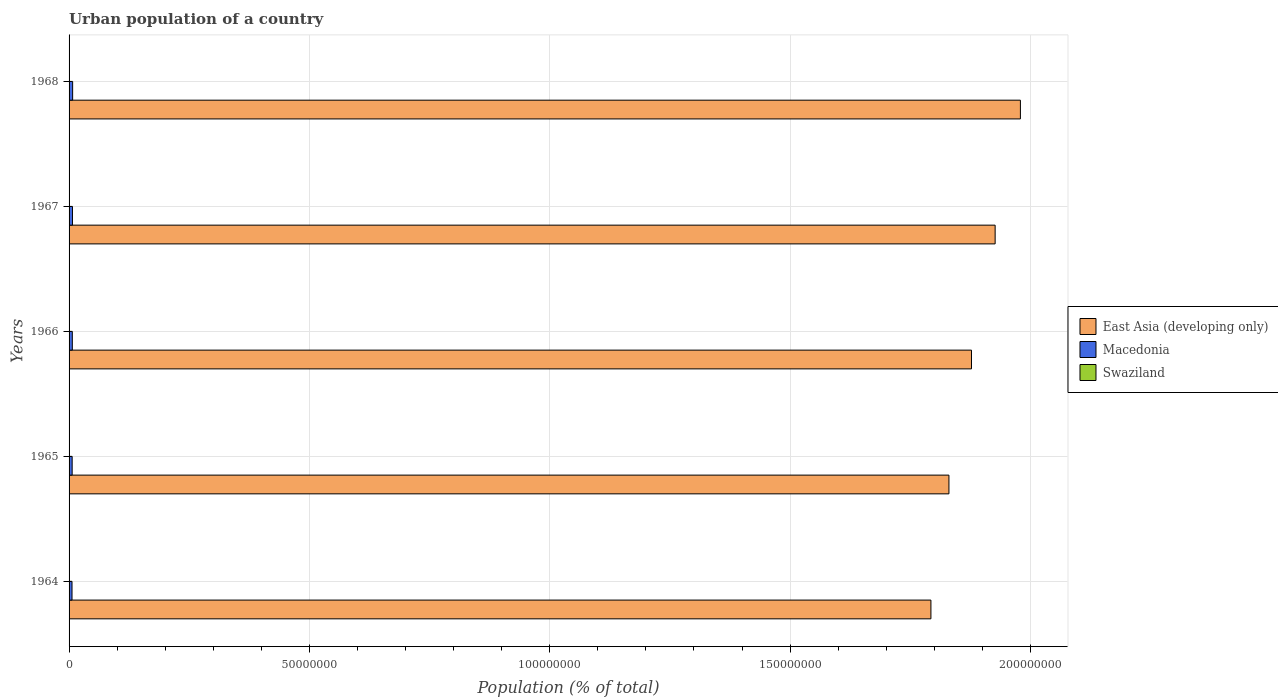How many different coloured bars are there?
Make the answer very short. 3. How many bars are there on the 5th tick from the top?
Ensure brevity in your answer.  3. What is the label of the 3rd group of bars from the top?
Provide a succinct answer. 1966. What is the urban population in East Asia (developing only) in 1967?
Offer a terse response. 1.93e+08. Across all years, what is the maximum urban population in Macedonia?
Offer a terse response. 7.42e+05. Across all years, what is the minimum urban population in East Asia (developing only)?
Offer a terse response. 1.79e+08. In which year was the urban population in East Asia (developing only) maximum?
Provide a short and direct response. 1968. In which year was the urban population in East Asia (developing only) minimum?
Give a very brief answer. 1964. What is the total urban population in Macedonia in the graph?
Keep it short and to the point. 3.38e+06. What is the difference between the urban population in East Asia (developing only) in 1966 and that in 1968?
Offer a terse response. -1.02e+07. What is the difference between the urban population in Macedonia in 1965 and the urban population in East Asia (developing only) in 1968?
Ensure brevity in your answer.  -1.97e+08. What is the average urban population in East Asia (developing only) per year?
Your response must be concise. 1.88e+08. In the year 1964, what is the difference between the urban population in East Asia (developing only) and urban population in Macedonia?
Your answer should be very brief. 1.79e+08. What is the ratio of the urban population in Macedonia in 1967 to that in 1968?
Ensure brevity in your answer.  0.95. Is the urban population in Swaziland in 1964 less than that in 1968?
Provide a short and direct response. Yes. Is the difference between the urban population in East Asia (developing only) in 1964 and 1965 greater than the difference between the urban population in Macedonia in 1964 and 1965?
Give a very brief answer. No. What is the difference between the highest and the second highest urban population in Macedonia?
Keep it short and to the point. 3.44e+04. What is the difference between the highest and the lowest urban population in East Asia (developing only)?
Offer a very short reply. 1.86e+07. Is the sum of the urban population in Swaziland in 1967 and 1968 greater than the maximum urban population in Macedonia across all years?
Keep it short and to the point. No. What does the 3rd bar from the top in 1967 represents?
Offer a very short reply. East Asia (developing only). What does the 2nd bar from the bottom in 1965 represents?
Give a very brief answer. Macedonia. How many bars are there?
Provide a succinct answer. 15. Are all the bars in the graph horizontal?
Make the answer very short. Yes. What is the difference between two consecutive major ticks on the X-axis?
Keep it short and to the point. 5.00e+07. Are the values on the major ticks of X-axis written in scientific E-notation?
Your answer should be compact. No. Does the graph contain any zero values?
Provide a succinct answer. No. How many legend labels are there?
Offer a very short reply. 3. How are the legend labels stacked?
Your response must be concise. Vertical. What is the title of the graph?
Keep it short and to the point. Urban population of a country. Does "Chad" appear as one of the legend labels in the graph?
Your answer should be compact. No. What is the label or title of the X-axis?
Ensure brevity in your answer.  Population (% of total). What is the Population (% of total) in East Asia (developing only) in 1964?
Ensure brevity in your answer.  1.79e+08. What is the Population (% of total) of Macedonia in 1964?
Provide a succinct answer. 6.13e+05. What is the Population (% of total) in Swaziland in 1964?
Make the answer very short. 2.25e+04. What is the Population (% of total) of East Asia (developing only) in 1965?
Make the answer very short. 1.83e+08. What is the Population (% of total) of Macedonia in 1965?
Your answer should be very brief. 6.43e+05. What is the Population (% of total) of Swaziland in 1965?
Make the answer very short. 2.54e+04. What is the Population (% of total) of East Asia (developing only) in 1966?
Your response must be concise. 1.88e+08. What is the Population (% of total) of Macedonia in 1966?
Your answer should be very brief. 6.74e+05. What is the Population (% of total) in Swaziland in 1966?
Provide a short and direct response. 2.87e+04. What is the Population (% of total) in East Asia (developing only) in 1967?
Ensure brevity in your answer.  1.93e+08. What is the Population (% of total) of Macedonia in 1967?
Your answer should be compact. 7.08e+05. What is the Population (% of total) of Swaziland in 1967?
Make the answer very short. 3.18e+04. What is the Population (% of total) of East Asia (developing only) in 1968?
Give a very brief answer. 1.98e+08. What is the Population (% of total) in Macedonia in 1968?
Provide a succinct answer. 7.42e+05. What is the Population (% of total) in Swaziland in 1968?
Your answer should be very brief. 3.52e+04. Across all years, what is the maximum Population (% of total) in East Asia (developing only)?
Provide a succinct answer. 1.98e+08. Across all years, what is the maximum Population (% of total) of Macedonia?
Provide a short and direct response. 7.42e+05. Across all years, what is the maximum Population (% of total) in Swaziland?
Make the answer very short. 3.52e+04. Across all years, what is the minimum Population (% of total) in East Asia (developing only)?
Make the answer very short. 1.79e+08. Across all years, what is the minimum Population (% of total) of Macedonia?
Offer a terse response. 6.13e+05. Across all years, what is the minimum Population (% of total) in Swaziland?
Provide a succinct answer. 2.25e+04. What is the total Population (% of total) in East Asia (developing only) in the graph?
Ensure brevity in your answer.  9.41e+08. What is the total Population (% of total) in Macedonia in the graph?
Give a very brief answer. 3.38e+06. What is the total Population (% of total) in Swaziland in the graph?
Offer a terse response. 1.44e+05. What is the difference between the Population (% of total) of East Asia (developing only) in 1964 and that in 1965?
Your answer should be very brief. -3.75e+06. What is the difference between the Population (% of total) in Macedonia in 1964 and that in 1965?
Provide a short and direct response. -2.99e+04. What is the difference between the Population (% of total) in Swaziland in 1964 and that in 1965?
Offer a very short reply. -2954. What is the difference between the Population (% of total) in East Asia (developing only) in 1964 and that in 1966?
Ensure brevity in your answer.  -8.44e+06. What is the difference between the Population (% of total) of Macedonia in 1964 and that in 1966?
Your answer should be very brief. -6.16e+04. What is the difference between the Population (% of total) in Swaziland in 1964 and that in 1966?
Keep it short and to the point. -6241. What is the difference between the Population (% of total) in East Asia (developing only) in 1964 and that in 1967?
Keep it short and to the point. -1.34e+07. What is the difference between the Population (% of total) in Macedonia in 1964 and that in 1967?
Your answer should be very brief. -9.49e+04. What is the difference between the Population (% of total) of Swaziland in 1964 and that in 1967?
Your answer should be very brief. -9323. What is the difference between the Population (% of total) of East Asia (developing only) in 1964 and that in 1968?
Offer a very short reply. -1.86e+07. What is the difference between the Population (% of total) of Macedonia in 1964 and that in 1968?
Keep it short and to the point. -1.29e+05. What is the difference between the Population (% of total) of Swaziland in 1964 and that in 1968?
Offer a terse response. -1.28e+04. What is the difference between the Population (% of total) of East Asia (developing only) in 1965 and that in 1966?
Offer a very short reply. -4.69e+06. What is the difference between the Population (% of total) of Macedonia in 1965 and that in 1966?
Provide a short and direct response. -3.17e+04. What is the difference between the Population (% of total) in Swaziland in 1965 and that in 1966?
Make the answer very short. -3287. What is the difference between the Population (% of total) in East Asia (developing only) in 1965 and that in 1967?
Your answer should be very brief. -9.61e+06. What is the difference between the Population (% of total) in Macedonia in 1965 and that in 1967?
Provide a short and direct response. -6.50e+04. What is the difference between the Population (% of total) of Swaziland in 1965 and that in 1967?
Ensure brevity in your answer.  -6369. What is the difference between the Population (% of total) in East Asia (developing only) in 1965 and that in 1968?
Provide a succinct answer. -1.49e+07. What is the difference between the Population (% of total) of Macedonia in 1965 and that in 1968?
Your response must be concise. -9.93e+04. What is the difference between the Population (% of total) of Swaziland in 1965 and that in 1968?
Provide a succinct answer. -9800. What is the difference between the Population (% of total) of East Asia (developing only) in 1966 and that in 1967?
Your answer should be compact. -4.92e+06. What is the difference between the Population (% of total) in Macedonia in 1966 and that in 1967?
Give a very brief answer. -3.33e+04. What is the difference between the Population (% of total) of Swaziland in 1966 and that in 1967?
Give a very brief answer. -3082. What is the difference between the Population (% of total) in East Asia (developing only) in 1966 and that in 1968?
Offer a terse response. -1.02e+07. What is the difference between the Population (% of total) in Macedonia in 1966 and that in 1968?
Your response must be concise. -6.76e+04. What is the difference between the Population (% of total) of Swaziland in 1966 and that in 1968?
Offer a terse response. -6513. What is the difference between the Population (% of total) in East Asia (developing only) in 1967 and that in 1968?
Offer a terse response. -5.26e+06. What is the difference between the Population (% of total) of Macedonia in 1967 and that in 1968?
Ensure brevity in your answer.  -3.44e+04. What is the difference between the Population (% of total) of Swaziland in 1967 and that in 1968?
Provide a short and direct response. -3431. What is the difference between the Population (% of total) of East Asia (developing only) in 1964 and the Population (% of total) of Macedonia in 1965?
Give a very brief answer. 1.79e+08. What is the difference between the Population (% of total) of East Asia (developing only) in 1964 and the Population (% of total) of Swaziland in 1965?
Your answer should be very brief. 1.79e+08. What is the difference between the Population (% of total) in Macedonia in 1964 and the Population (% of total) in Swaziland in 1965?
Your response must be concise. 5.87e+05. What is the difference between the Population (% of total) of East Asia (developing only) in 1964 and the Population (% of total) of Macedonia in 1966?
Give a very brief answer. 1.79e+08. What is the difference between the Population (% of total) of East Asia (developing only) in 1964 and the Population (% of total) of Swaziland in 1966?
Provide a short and direct response. 1.79e+08. What is the difference between the Population (% of total) of Macedonia in 1964 and the Population (% of total) of Swaziland in 1966?
Offer a very short reply. 5.84e+05. What is the difference between the Population (% of total) of East Asia (developing only) in 1964 and the Population (% of total) of Macedonia in 1967?
Offer a very short reply. 1.79e+08. What is the difference between the Population (% of total) of East Asia (developing only) in 1964 and the Population (% of total) of Swaziland in 1967?
Provide a succinct answer. 1.79e+08. What is the difference between the Population (% of total) of Macedonia in 1964 and the Population (% of total) of Swaziland in 1967?
Make the answer very short. 5.81e+05. What is the difference between the Population (% of total) of East Asia (developing only) in 1964 and the Population (% of total) of Macedonia in 1968?
Your answer should be compact. 1.79e+08. What is the difference between the Population (% of total) in East Asia (developing only) in 1964 and the Population (% of total) in Swaziland in 1968?
Offer a terse response. 1.79e+08. What is the difference between the Population (% of total) of Macedonia in 1964 and the Population (% of total) of Swaziland in 1968?
Keep it short and to the point. 5.77e+05. What is the difference between the Population (% of total) in East Asia (developing only) in 1965 and the Population (% of total) in Macedonia in 1966?
Your answer should be very brief. 1.82e+08. What is the difference between the Population (% of total) of East Asia (developing only) in 1965 and the Population (% of total) of Swaziland in 1966?
Ensure brevity in your answer.  1.83e+08. What is the difference between the Population (% of total) of Macedonia in 1965 and the Population (% of total) of Swaziland in 1966?
Your answer should be compact. 6.14e+05. What is the difference between the Population (% of total) in East Asia (developing only) in 1965 and the Population (% of total) in Macedonia in 1967?
Offer a terse response. 1.82e+08. What is the difference between the Population (% of total) of East Asia (developing only) in 1965 and the Population (% of total) of Swaziland in 1967?
Your answer should be very brief. 1.83e+08. What is the difference between the Population (% of total) of Macedonia in 1965 and the Population (% of total) of Swaziland in 1967?
Ensure brevity in your answer.  6.11e+05. What is the difference between the Population (% of total) of East Asia (developing only) in 1965 and the Population (% of total) of Macedonia in 1968?
Ensure brevity in your answer.  1.82e+08. What is the difference between the Population (% of total) in East Asia (developing only) in 1965 and the Population (% of total) in Swaziland in 1968?
Provide a short and direct response. 1.83e+08. What is the difference between the Population (% of total) of Macedonia in 1965 and the Population (% of total) of Swaziland in 1968?
Provide a succinct answer. 6.07e+05. What is the difference between the Population (% of total) of East Asia (developing only) in 1966 and the Population (% of total) of Macedonia in 1967?
Ensure brevity in your answer.  1.87e+08. What is the difference between the Population (% of total) in East Asia (developing only) in 1966 and the Population (% of total) in Swaziland in 1967?
Your answer should be very brief. 1.88e+08. What is the difference between the Population (% of total) in Macedonia in 1966 and the Population (% of total) in Swaziland in 1967?
Your answer should be compact. 6.42e+05. What is the difference between the Population (% of total) in East Asia (developing only) in 1966 and the Population (% of total) in Macedonia in 1968?
Make the answer very short. 1.87e+08. What is the difference between the Population (% of total) in East Asia (developing only) in 1966 and the Population (% of total) in Swaziland in 1968?
Ensure brevity in your answer.  1.88e+08. What is the difference between the Population (% of total) of Macedonia in 1966 and the Population (% of total) of Swaziland in 1968?
Your answer should be very brief. 6.39e+05. What is the difference between the Population (% of total) of East Asia (developing only) in 1967 and the Population (% of total) of Macedonia in 1968?
Your response must be concise. 1.92e+08. What is the difference between the Population (% of total) in East Asia (developing only) in 1967 and the Population (% of total) in Swaziland in 1968?
Give a very brief answer. 1.93e+08. What is the difference between the Population (% of total) of Macedonia in 1967 and the Population (% of total) of Swaziland in 1968?
Your response must be concise. 6.72e+05. What is the average Population (% of total) in East Asia (developing only) per year?
Offer a terse response. 1.88e+08. What is the average Population (% of total) in Macedonia per year?
Your answer should be compact. 6.76e+05. What is the average Population (% of total) in Swaziland per year?
Provide a succinct answer. 2.87e+04. In the year 1964, what is the difference between the Population (% of total) in East Asia (developing only) and Population (% of total) in Macedonia?
Your answer should be compact. 1.79e+08. In the year 1964, what is the difference between the Population (% of total) of East Asia (developing only) and Population (% of total) of Swaziland?
Give a very brief answer. 1.79e+08. In the year 1964, what is the difference between the Population (% of total) of Macedonia and Population (% of total) of Swaziland?
Give a very brief answer. 5.90e+05. In the year 1965, what is the difference between the Population (% of total) in East Asia (developing only) and Population (% of total) in Macedonia?
Make the answer very short. 1.82e+08. In the year 1965, what is the difference between the Population (% of total) in East Asia (developing only) and Population (% of total) in Swaziland?
Offer a terse response. 1.83e+08. In the year 1965, what is the difference between the Population (% of total) in Macedonia and Population (% of total) in Swaziland?
Ensure brevity in your answer.  6.17e+05. In the year 1966, what is the difference between the Population (% of total) in East Asia (developing only) and Population (% of total) in Macedonia?
Offer a very short reply. 1.87e+08. In the year 1966, what is the difference between the Population (% of total) of East Asia (developing only) and Population (% of total) of Swaziland?
Your response must be concise. 1.88e+08. In the year 1966, what is the difference between the Population (% of total) in Macedonia and Population (% of total) in Swaziland?
Offer a terse response. 6.46e+05. In the year 1967, what is the difference between the Population (% of total) of East Asia (developing only) and Population (% of total) of Macedonia?
Your answer should be very brief. 1.92e+08. In the year 1967, what is the difference between the Population (% of total) in East Asia (developing only) and Population (% of total) in Swaziland?
Provide a short and direct response. 1.93e+08. In the year 1967, what is the difference between the Population (% of total) of Macedonia and Population (% of total) of Swaziland?
Ensure brevity in your answer.  6.76e+05. In the year 1968, what is the difference between the Population (% of total) of East Asia (developing only) and Population (% of total) of Macedonia?
Offer a very short reply. 1.97e+08. In the year 1968, what is the difference between the Population (% of total) in East Asia (developing only) and Population (% of total) in Swaziland?
Give a very brief answer. 1.98e+08. In the year 1968, what is the difference between the Population (% of total) of Macedonia and Population (% of total) of Swaziland?
Provide a short and direct response. 7.07e+05. What is the ratio of the Population (% of total) of East Asia (developing only) in 1964 to that in 1965?
Make the answer very short. 0.98. What is the ratio of the Population (% of total) of Macedonia in 1964 to that in 1965?
Offer a terse response. 0.95. What is the ratio of the Population (% of total) of Swaziland in 1964 to that in 1965?
Your answer should be compact. 0.88. What is the ratio of the Population (% of total) in East Asia (developing only) in 1964 to that in 1966?
Keep it short and to the point. 0.95. What is the ratio of the Population (% of total) of Macedonia in 1964 to that in 1966?
Your answer should be compact. 0.91. What is the ratio of the Population (% of total) of Swaziland in 1964 to that in 1966?
Ensure brevity in your answer.  0.78. What is the ratio of the Population (% of total) of East Asia (developing only) in 1964 to that in 1967?
Your answer should be very brief. 0.93. What is the ratio of the Population (% of total) in Macedonia in 1964 to that in 1967?
Keep it short and to the point. 0.87. What is the ratio of the Population (% of total) in Swaziland in 1964 to that in 1967?
Your response must be concise. 0.71. What is the ratio of the Population (% of total) in East Asia (developing only) in 1964 to that in 1968?
Ensure brevity in your answer.  0.91. What is the ratio of the Population (% of total) of Macedonia in 1964 to that in 1968?
Keep it short and to the point. 0.83. What is the ratio of the Population (% of total) in Swaziland in 1964 to that in 1968?
Give a very brief answer. 0.64. What is the ratio of the Population (% of total) of East Asia (developing only) in 1965 to that in 1966?
Keep it short and to the point. 0.97. What is the ratio of the Population (% of total) in Macedonia in 1965 to that in 1966?
Your answer should be very brief. 0.95. What is the ratio of the Population (% of total) of Swaziland in 1965 to that in 1966?
Give a very brief answer. 0.89. What is the ratio of the Population (% of total) in East Asia (developing only) in 1965 to that in 1967?
Offer a terse response. 0.95. What is the ratio of the Population (% of total) in Macedonia in 1965 to that in 1967?
Provide a short and direct response. 0.91. What is the ratio of the Population (% of total) of Swaziland in 1965 to that in 1967?
Your response must be concise. 0.8. What is the ratio of the Population (% of total) of East Asia (developing only) in 1965 to that in 1968?
Your answer should be very brief. 0.92. What is the ratio of the Population (% of total) of Macedonia in 1965 to that in 1968?
Give a very brief answer. 0.87. What is the ratio of the Population (% of total) in Swaziland in 1965 to that in 1968?
Ensure brevity in your answer.  0.72. What is the ratio of the Population (% of total) in East Asia (developing only) in 1966 to that in 1967?
Your answer should be very brief. 0.97. What is the ratio of the Population (% of total) in Macedonia in 1966 to that in 1967?
Ensure brevity in your answer.  0.95. What is the ratio of the Population (% of total) in Swaziland in 1966 to that in 1967?
Your answer should be compact. 0.9. What is the ratio of the Population (% of total) of East Asia (developing only) in 1966 to that in 1968?
Your response must be concise. 0.95. What is the ratio of the Population (% of total) of Macedonia in 1966 to that in 1968?
Provide a short and direct response. 0.91. What is the ratio of the Population (% of total) of Swaziland in 1966 to that in 1968?
Offer a very short reply. 0.82. What is the ratio of the Population (% of total) of East Asia (developing only) in 1967 to that in 1968?
Offer a terse response. 0.97. What is the ratio of the Population (% of total) in Macedonia in 1967 to that in 1968?
Offer a very short reply. 0.95. What is the ratio of the Population (% of total) of Swaziland in 1967 to that in 1968?
Make the answer very short. 0.9. What is the difference between the highest and the second highest Population (% of total) of East Asia (developing only)?
Your answer should be compact. 5.26e+06. What is the difference between the highest and the second highest Population (% of total) of Macedonia?
Give a very brief answer. 3.44e+04. What is the difference between the highest and the second highest Population (% of total) in Swaziland?
Ensure brevity in your answer.  3431. What is the difference between the highest and the lowest Population (% of total) of East Asia (developing only)?
Make the answer very short. 1.86e+07. What is the difference between the highest and the lowest Population (% of total) of Macedonia?
Give a very brief answer. 1.29e+05. What is the difference between the highest and the lowest Population (% of total) in Swaziland?
Keep it short and to the point. 1.28e+04. 